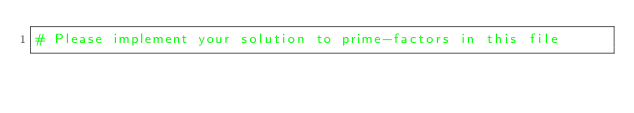<code> <loc_0><loc_0><loc_500><loc_500><_Crystal_># Please implement your solution to prime-factors in this file
</code> 